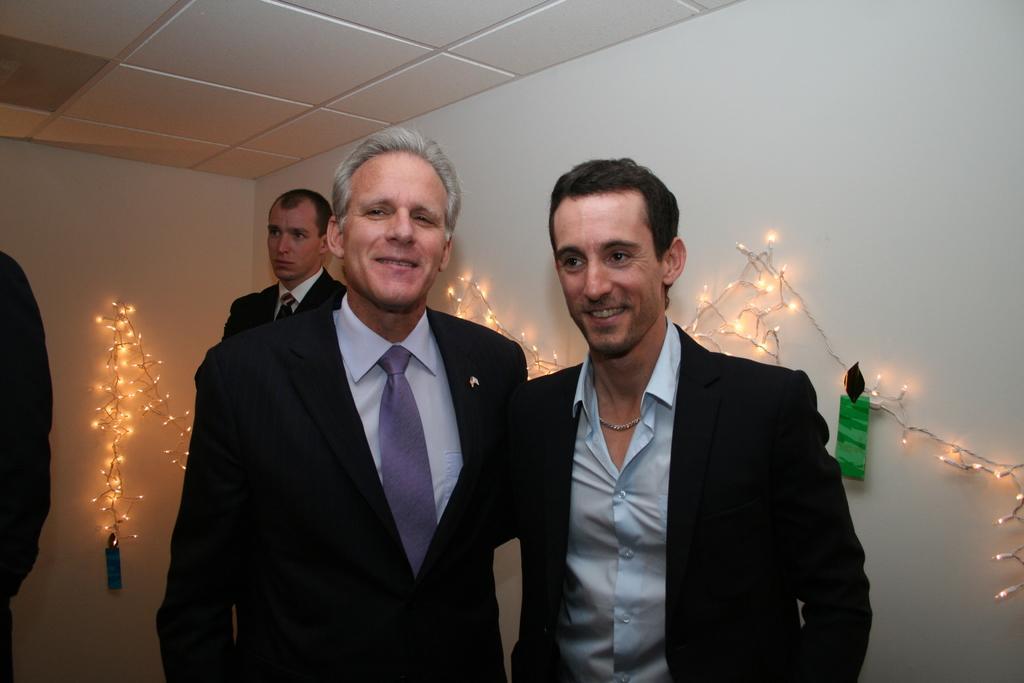Can you describe this image briefly? In the image there are two men standing and they are smiling. Behind them there is a man standing. On the left corner of the image there is a person. In the background there are walls with decorative lights. At the top of the image there is a ceiling. 